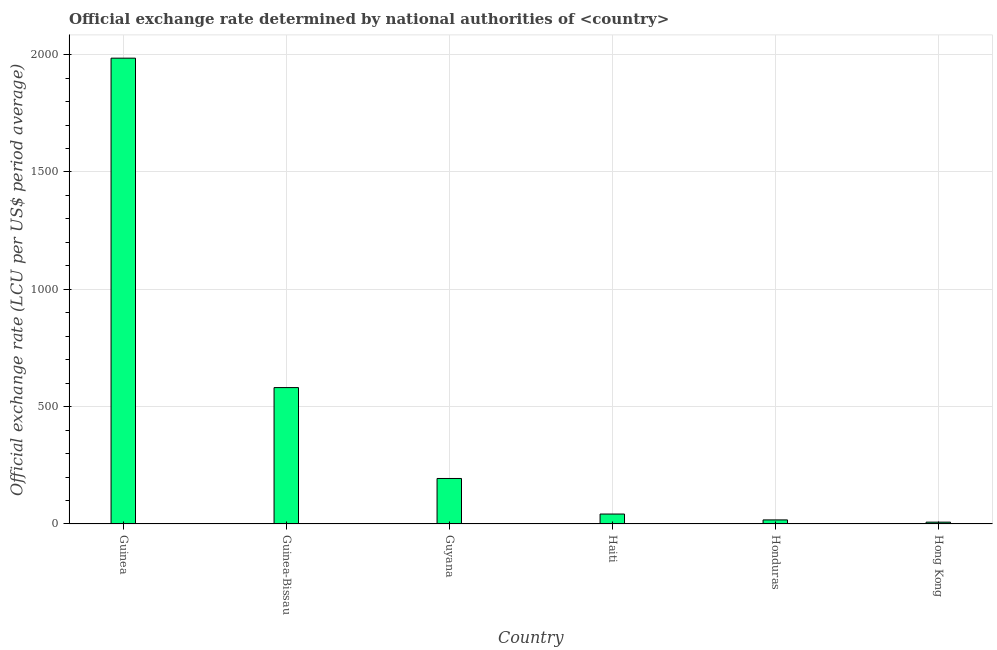Does the graph contain any zero values?
Offer a terse response. No. Does the graph contain grids?
Ensure brevity in your answer.  Yes. What is the title of the graph?
Your answer should be very brief. Official exchange rate determined by national authorities of <country>. What is the label or title of the Y-axis?
Your answer should be very brief. Official exchange rate (LCU per US$ period average). What is the official exchange rate in Guinea-Bissau?
Offer a very short reply. 581.2. Across all countries, what is the maximum official exchange rate?
Offer a terse response. 1984.93. Across all countries, what is the minimum official exchange rate?
Ensure brevity in your answer.  7.79. In which country was the official exchange rate maximum?
Offer a terse response. Guinea. In which country was the official exchange rate minimum?
Ensure brevity in your answer.  Hong Kong. What is the sum of the official exchange rate?
Your answer should be compact. 2827.51. What is the difference between the official exchange rate in Guinea and Guinea-Bissau?
Provide a succinct answer. 1403.73. What is the average official exchange rate per country?
Provide a short and direct response. 471.25. What is the median official exchange rate?
Give a very brief answer. 118.12. What is the ratio of the official exchange rate in Guyana to that in Hong Kong?
Give a very brief answer. 24.9. What is the difference between the highest and the second highest official exchange rate?
Offer a very short reply. 1403.73. Is the sum of the official exchange rate in Guinea-Bissau and Hong Kong greater than the maximum official exchange rate across all countries?
Provide a short and direct response. No. What is the difference between the highest and the lowest official exchange rate?
Provide a succinct answer. 1977.14. How many bars are there?
Provide a succinct answer. 6. Are all the bars in the graph horizontal?
Provide a short and direct response. No. What is the difference between two consecutive major ticks on the Y-axis?
Your answer should be very brief. 500. What is the Official exchange rate (LCU per US$ period average) of Guinea?
Your answer should be compact. 1984.93. What is the Official exchange rate (LCU per US$ period average) of Guinea-Bissau?
Keep it short and to the point. 581.2. What is the Official exchange rate (LCU per US$ period average) in Guyana?
Keep it short and to the point. 193.88. What is the Official exchange rate (LCU per US$ period average) in Haiti?
Keep it short and to the point. 42.37. What is the Official exchange rate (LCU per US$ period average) in Honduras?
Your answer should be very brief. 17.35. What is the Official exchange rate (LCU per US$ period average) in Hong Kong?
Keep it short and to the point. 7.79. What is the difference between the Official exchange rate (LCU per US$ period average) in Guinea and Guinea-Bissau?
Your answer should be very brief. 1403.73. What is the difference between the Official exchange rate (LCU per US$ period average) in Guinea and Guyana?
Give a very brief answer. 1791.05. What is the difference between the Official exchange rate (LCU per US$ period average) in Guinea and Haiti?
Offer a very short reply. 1942.56. What is the difference between the Official exchange rate (LCU per US$ period average) in Guinea and Honduras?
Provide a succinct answer. 1967.59. What is the difference between the Official exchange rate (LCU per US$ period average) in Guinea and Hong Kong?
Give a very brief answer. 1977.14. What is the difference between the Official exchange rate (LCU per US$ period average) in Guinea-Bissau and Guyana?
Your answer should be very brief. 387.32. What is the difference between the Official exchange rate (LCU per US$ period average) in Guinea-Bissau and Haiti?
Ensure brevity in your answer.  538.83. What is the difference between the Official exchange rate (LCU per US$ period average) in Guinea-Bissau and Honduras?
Provide a succinct answer. 563.86. What is the difference between the Official exchange rate (LCU per US$ period average) in Guinea-Bissau and Hong Kong?
Offer a very short reply. 573.41. What is the difference between the Official exchange rate (LCU per US$ period average) in Guyana and Haiti?
Provide a short and direct response. 151.51. What is the difference between the Official exchange rate (LCU per US$ period average) in Guyana and Honduras?
Your answer should be very brief. 176.53. What is the difference between the Official exchange rate (LCU per US$ period average) in Guyana and Hong Kong?
Your answer should be very brief. 186.09. What is the difference between the Official exchange rate (LCU per US$ period average) in Haiti and Honduras?
Provide a succinct answer. 25.02. What is the difference between the Official exchange rate (LCU per US$ period average) in Haiti and Hong Kong?
Provide a succinct answer. 34.58. What is the difference between the Official exchange rate (LCU per US$ period average) in Honduras and Hong Kong?
Give a very brief answer. 9.56. What is the ratio of the Official exchange rate (LCU per US$ period average) in Guinea to that in Guinea-Bissau?
Your response must be concise. 3.42. What is the ratio of the Official exchange rate (LCU per US$ period average) in Guinea to that in Guyana?
Keep it short and to the point. 10.24. What is the ratio of the Official exchange rate (LCU per US$ period average) in Guinea to that in Haiti?
Your answer should be compact. 46.85. What is the ratio of the Official exchange rate (LCU per US$ period average) in Guinea to that in Honduras?
Keep it short and to the point. 114.44. What is the ratio of the Official exchange rate (LCU per US$ period average) in Guinea to that in Hong Kong?
Offer a terse response. 254.91. What is the ratio of the Official exchange rate (LCU per US$ period average) in Guinea-Bissau to that in Guyana?
Give a very brief answer. 3. What is the ratio of the Official exchange rate (LCU per US$ period average) in Guinea-Bissau to that in Haiti?
Your response must be concise. 13.72. What is the ratio of the Official exchange rate (LCU per US$ period average) in Guinea-Bissau to that in Honduras?
Offer a terse response. 33.51. What is the ratio of the Official exchange rate (LCU per US$ period average) in Guinea-Bissau to that in Hong Kong?
Provide a succinct answer. 74.64. What is the ratio of the Official exchange rate (LCU per US$ period average) in Guyana to that in Haiti?
Make the answer very short. 4.58. What is the ratio of the Official exchange rate (LCU per US$ period average) in Guyana to that in Honduras?
Make the answer very short. 11.18. What is the ratio of the Official exchange rate (LCU per US$ period average) in Guyana to that in Hong Kong?
Provide a succinct answer. 24.9. What is the ratio of the Official exchange rate (LCU per US$ period average) in Haiti to that in Honduras?
Your answer should be very brief. 2.44. What is the ratio of the Official exchange rate (LCU per US$ period average) in Haiti to that in Hong Kong?
Offer a very short reply. 5.44. What is the ratio of the Official exchange rate (LCU per US$ period average) in Honduras to that in Hong Kong?
Your answer should be very brief. 2.23. 